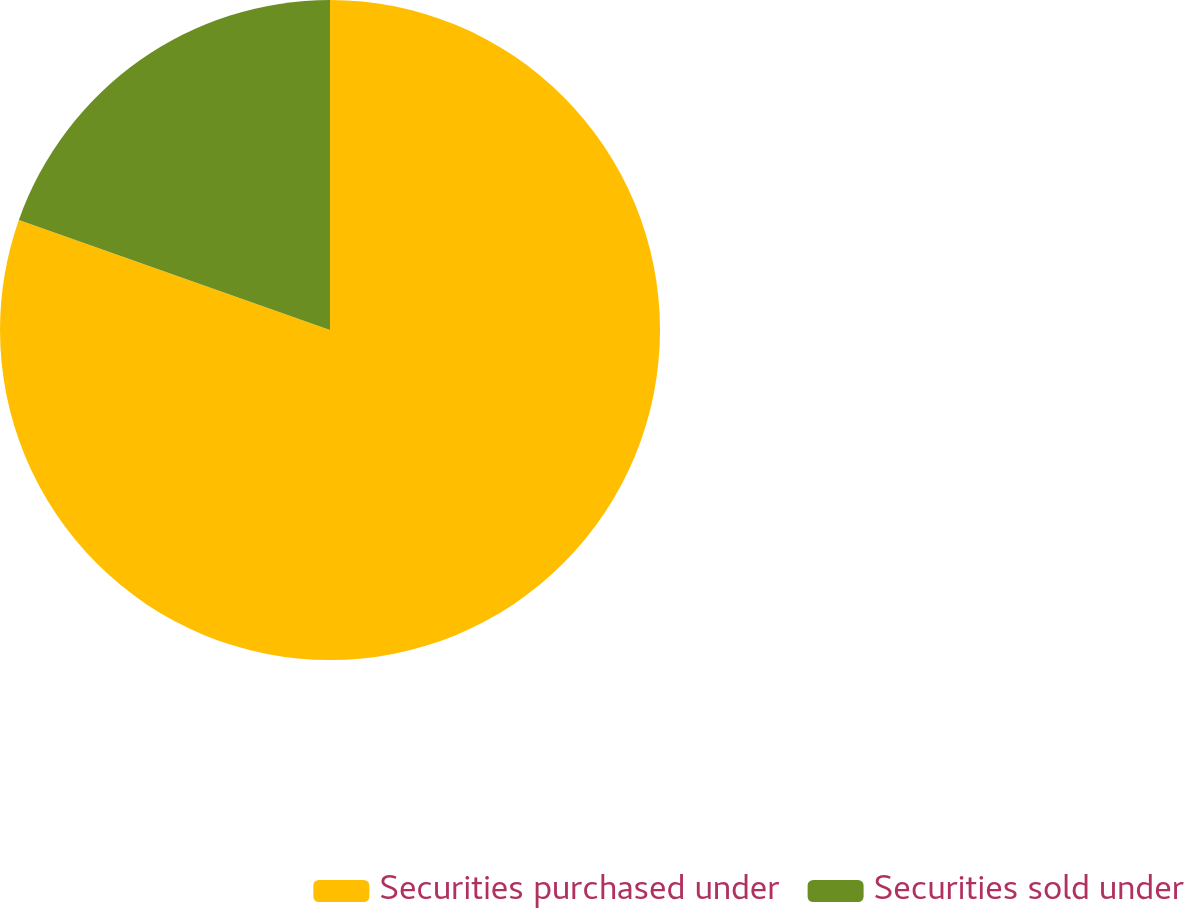Convert chart to OTSL. <chart><loc_0><loc_0><loc_500><loc_500><pie_chart><fcel>Securities purchased under<fcel>Securities sold under<nl><fcel>80.41%<fcel>19.59%<nl></chart> 